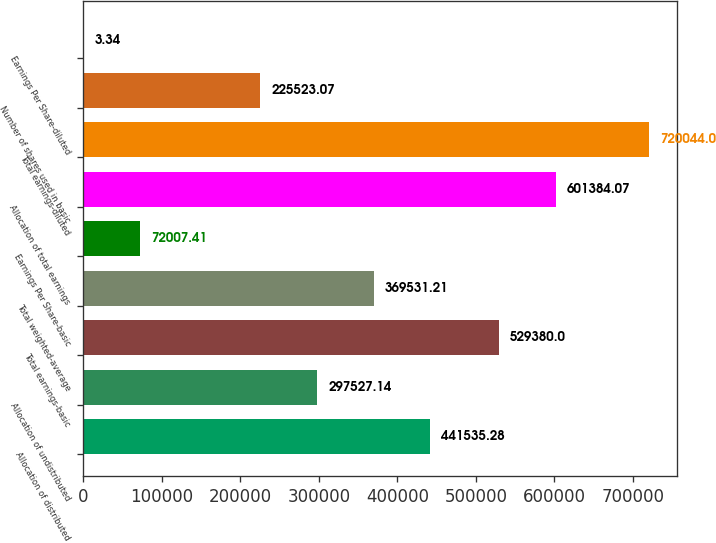<chart> <loc_0><loc_0><loc_500><loc_500><bar_chart><fcel>Allocation of distributed<fcel>Allocation of undistributed<fcel>Total earnings-basic<fcel>Total weighted-average<fcel>Earnings Per Share-basic<fcel>Allocation of total earnings<fcel>Total earnings-diluted<fcel>Number of shares used in basic<fcel>Earnings Per Share-diluted<nl><fcel>441535<fcel>297527<fcel>529380<fcel>369531<fcel>72007.4<fcel>601384<fcel>720044<fcel>225523<fcel>3.34<nl></chart> 